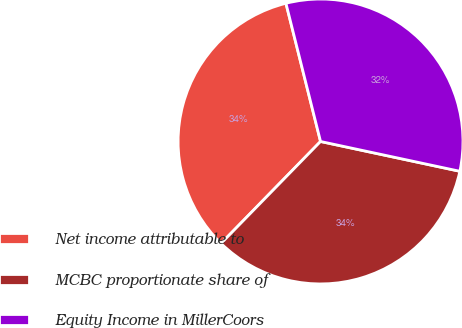Convert chart. <chart><loc_0><loc_0><loc_500><loc_500><pie_chart><fcel>Net income attributable to<fcel>MCBC proportionate share of<fcel>Equity Income in MillerCoors<nl><fcel>33.79%<fcel>33.95%<fcel>32.26%<nl></chart> 